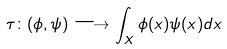<formula> <loc_0><loc_0><loc_500><loc_500>\tau \colon ( \phi , \psi ) \longrightarrow \int _ { X } \phi ( x ) \psi ( x ) d x</formula> 